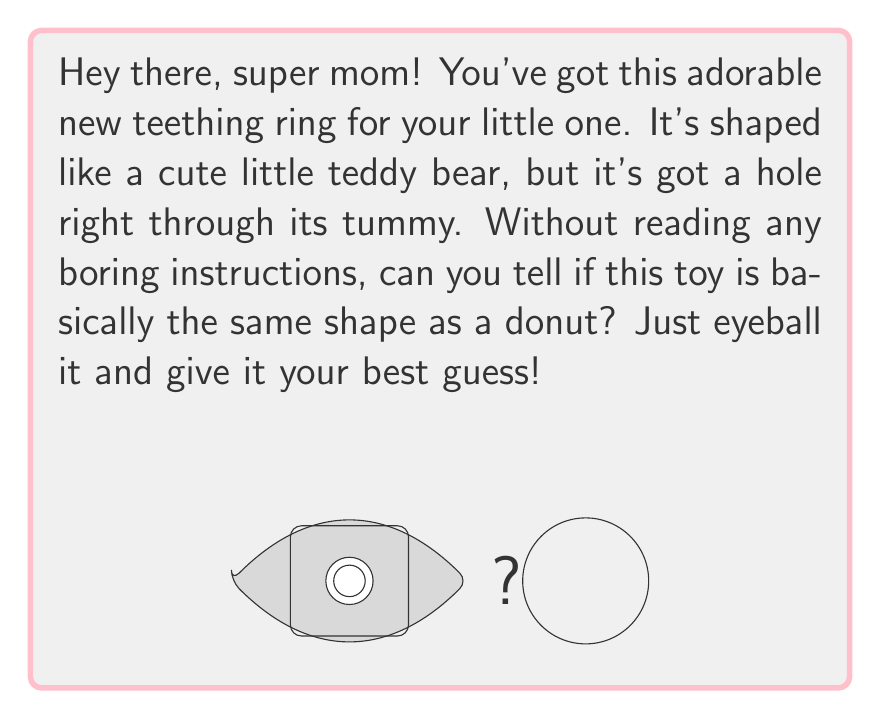Give your solution to this math problem. Alright, let's break this down in a way that doesn't feel like reading a manual:

1. First, let's think about what makes a shape "basically the same" in topology. It's all about whether you can squish, stretch, or bend one shape into another without cutting or gluing.

2. Now, look at that teddy bear teething ring. The key feature here is that hole in its tummy. That's super important!

3. A donut (or in math-speak, a torus) also has one hole going through it. If you imagine the teddy bear as being made of really stretchy rubber, you could:
   - Squish its arms and legs into its body
   - Stretch out the body into a ring shape
   - Smooth out any bumps

4. The mathematical way to say this is that both shapes have a "genus" of 1, meaning they each have one hole.

5. Here's the cool part: no matter how much you squish or stretch that teddy bear, as long as you don't tear it or close up that tummy hole, it'll always have that one hole - just like a donut!

6. In topology, we don't care about the exact shape or size, just the fundamental structure. Both the teddy bear and the donut have one continuous surface with one hole through it.

So, without getting into any complicated math formulas, your mom instincts are spot on if you thought these shapes were basically the same!
Answer: Yes, topologically equivalent 